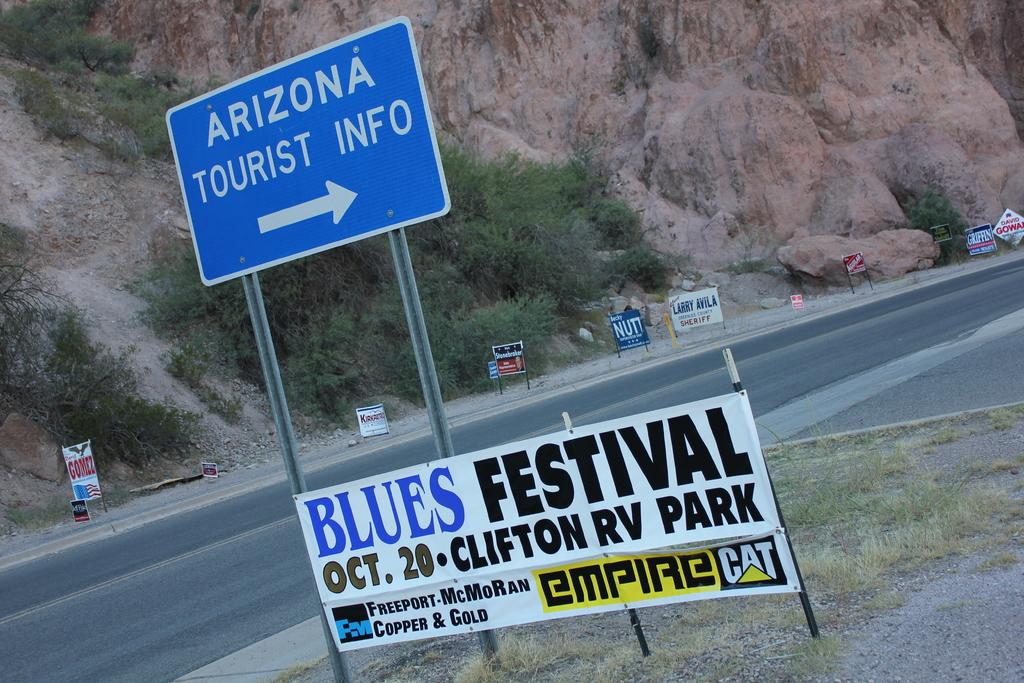<image>
Share a concise interpretation of the image provided. road signs for Blues Festival and Arizona Tourist info on the side of a road 